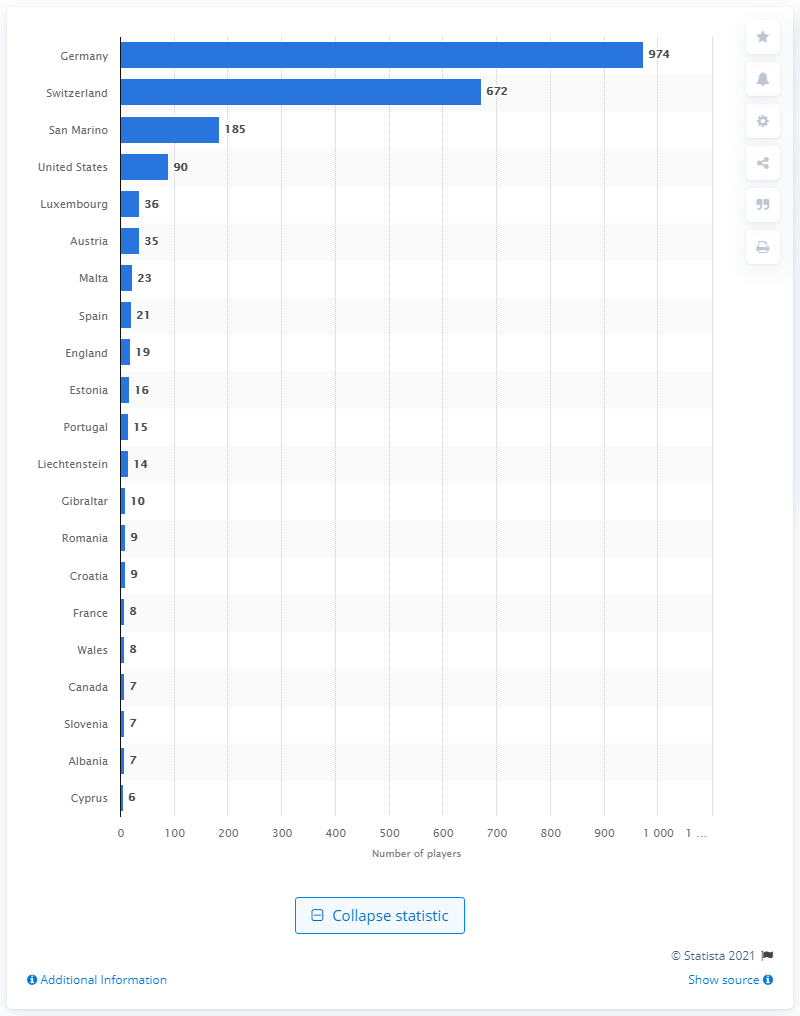Highlight a few significant elements in this photo. Many Italian footballers have played in Switzerland. As of January 2021, 974 professional footballers from Italy were playing in German clubs. 